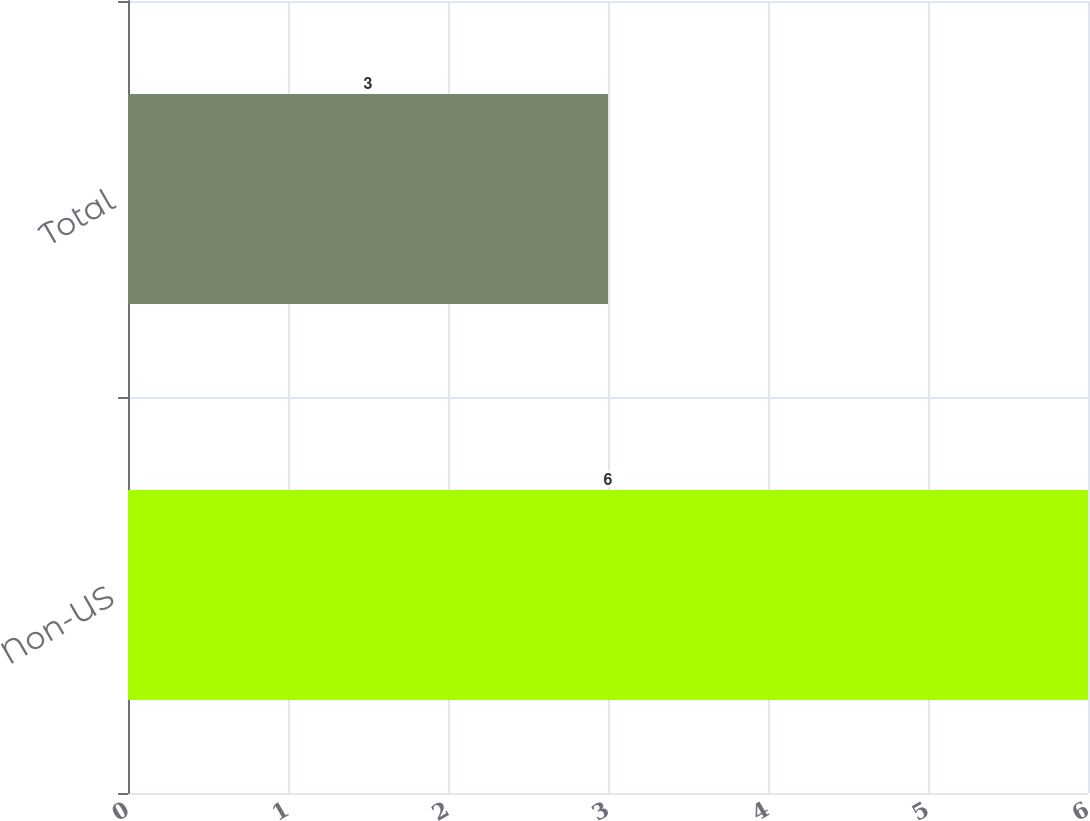<chart> <loc_0><loc_0><loc_500><loc_500><bar_chart><fcel>Non-US<fcel>Total<nl><fcel>6<fcel>3<nl></chart> 